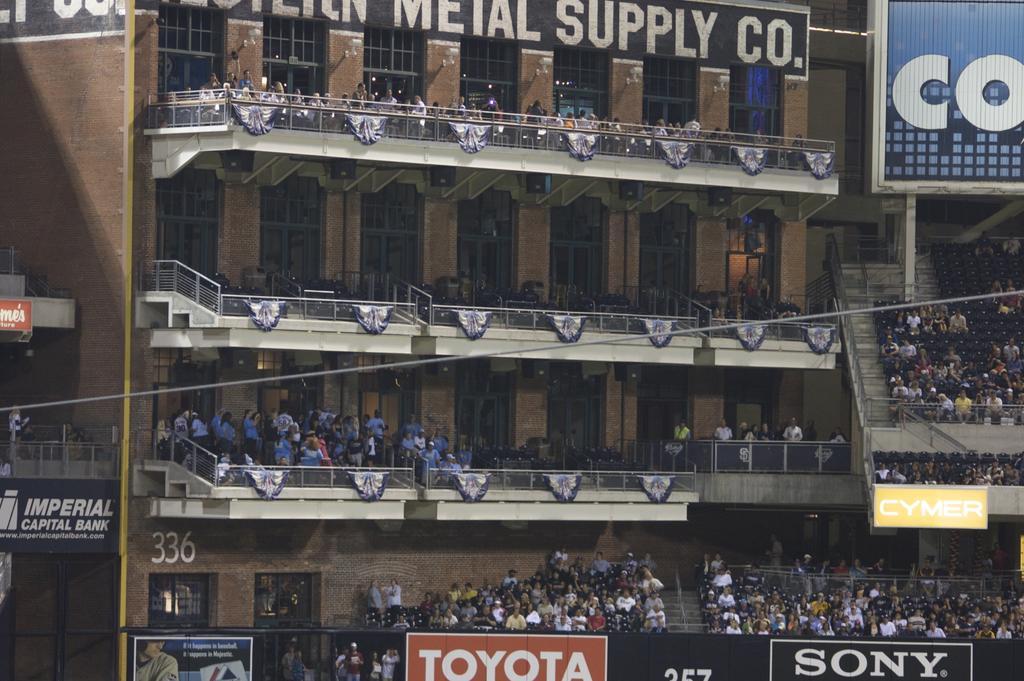How would you summarize this image in a sentence or two? In the picture it looks like a stadium building, there is a huge crowd in each floor of the stadium and in the foreground there are company names. 